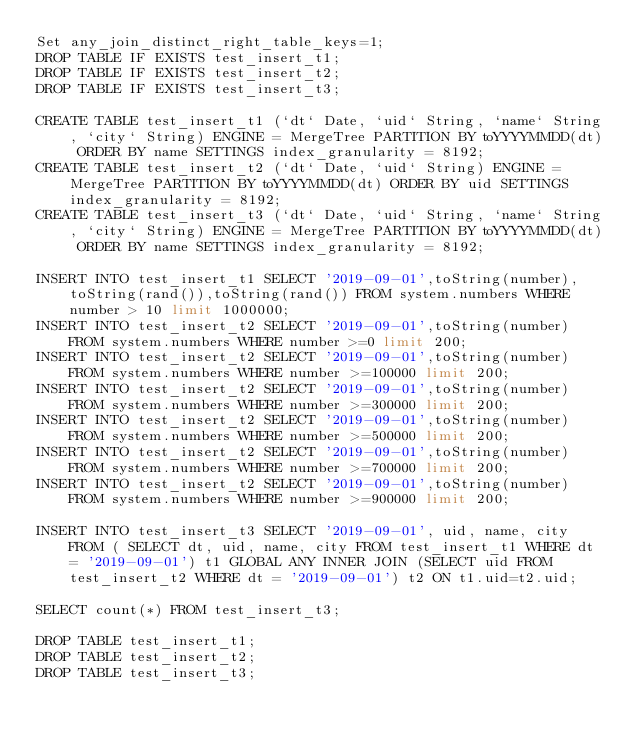<code> <loc_0><loc_0><loc_500><loc_500><_SQL_>Set any_join_distinct_right_table_keys=1;
DROP TABLE IF EXISTS test_insert_t1;
DROP TABLE IF EXISTS test_insert_t2;
DROP TABLE IF EXISTS test_insert_t3;

CREATE TABLE test_insert_t1 (`dt` Date, `uid` String, `name` String, `city` String) ENGINE = MergeTree PARTITION BY toYYYYMMDD(dt) ORDER BY name SETTINGS index_granularity = 8192;
CREATE TABLE test_insert_t2 (`dt` Date, `uid` String) ENGINE = MergeTree PARTITION BY toYYYYMMDD(dt) ORDER BY uid SETTINGS index_granularity = 8192;
CREATE TABLE test_insert_t3 (`dt` Date, `uid` String, `name` String, `city` String) ENGINE = MergeTree PARTITION BY toYYYYMMDD(dt) ORDER BY name SETTINGS index_granularity = 8192;

INSERT INTO test_insert_t1 SELECT '2019-09-01',toString(number),toString(rand()),toString(rand()) FROM system.numbers WHERE number > 10 limit 1000000;
INSERT INTO test_insert_t2 SELECT '2019-09-01',toString(number) FROM system.numbers WHERE number >=0 limit 200;
INSERT INTO test_insert_t2 SELECT '2019-09-01',toString(number) FROM system.numbers WHERE number >=100000 limit 200;
INSERT INTO test_insert_t2 SELECT '2019-09-01',toString(number) FROM system.numbers WHERE number >=300000 limit 200;
INSERT INTO test_insert_t2 SELECT '2019-09-01',toString(number) FROM system.numbers WHERE number >=500000 limit 200;
INSERT INTO test_insert_t2 SELECT '2019-09-01',toString(number) FROM system.numbers WHERE number >=700000 limit 200;
INSERT INTO test_insert_t2 SELECT '2019-09-01',toString(number) FROM system.numbers WHERE number >=900000 limit 200;

INSERT INTO test_insert_t3 SELECT '2019-09-01', uid, name, city FROM ( SELECT dt, uid, name, city FROM test_insert_t1 WHERE dt = '2019-09-01') t1 GLOBAL ANY INNER JOIN (SELECT uid FROM test_insert_t2 WHERE dt = '2019-09-01') t2 ON t1.uid=t2.uid;

SELECT count(*) FROM test_insert_t3;

DROP TABLE test_insert_t1;
DROP TABLE test_insert_t2;
DROP TABLE test_insert_t3;
</code> 